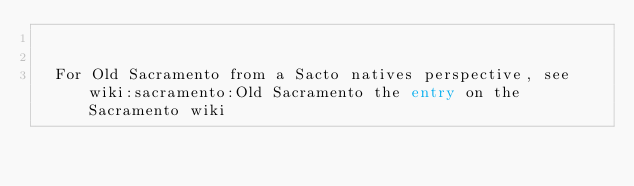<code> <loc_0><loc_0><loc_500><loc_500><_FORTRAN_>
 
  For Old Sacramento from a Sacto natives perspective, see wiki:sacramento:Old Sacramento the entry on the Sacramento wiki


</code> 